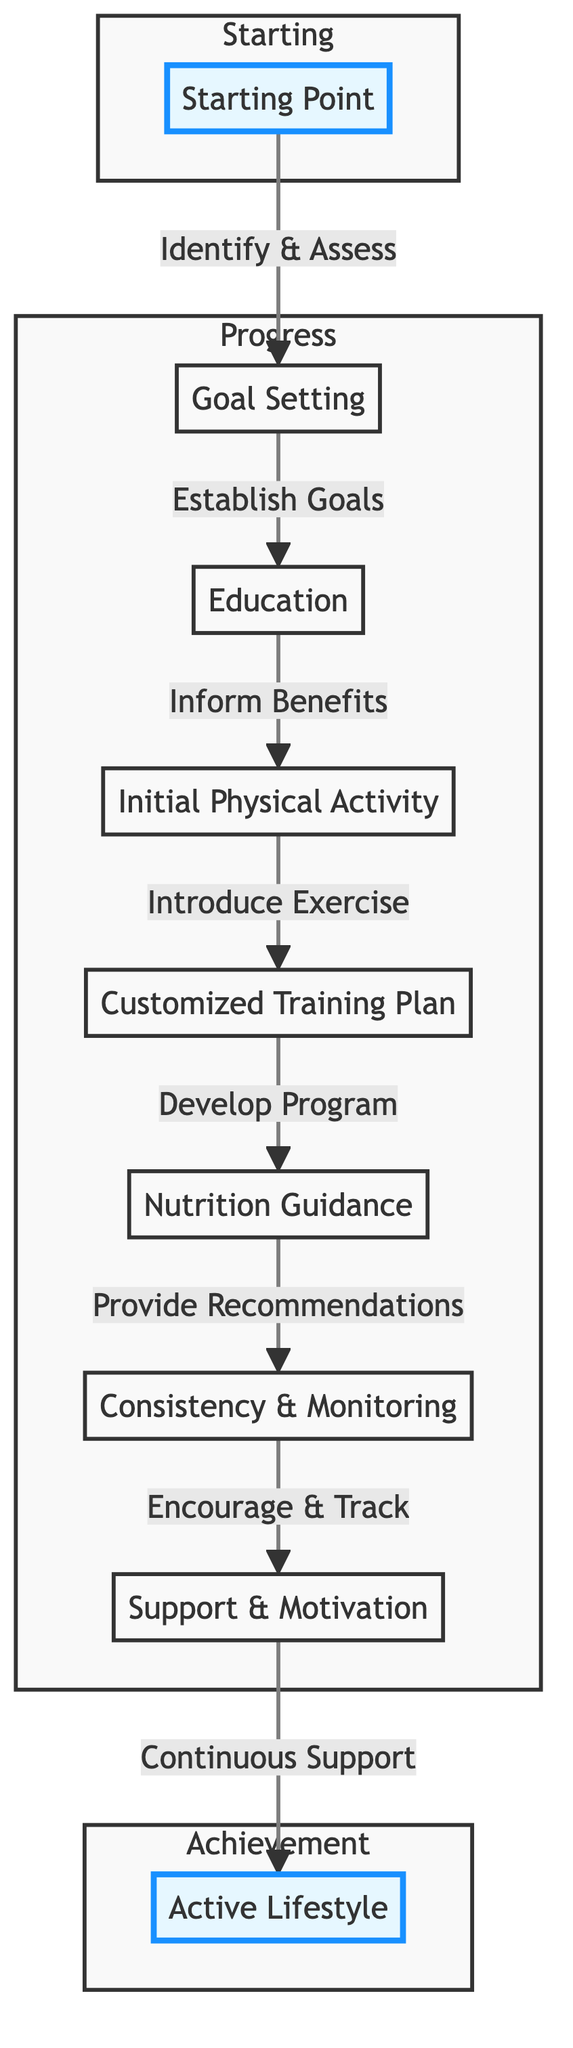What's the starting point in the client's journey? The starting point is indicated as the first node in the diagram, which describes the identification of a sedentary lifestyle and readiness to change.
Answer: Starting Point How many total stages are in the client’s journey? To find the total stages, count the nodes present in the flow chart. There are nine stages from Starting Point to Active Lifestyle.
Answer: 9 Which stage comes after Goal Setting? The flow of the diagram shows that the first stage leads to the next; after Goal Setting, the client moves to the Education stage.
Answer: Education What activity is included in the Initial Physical Activity stage? By examining the details of the Initial Physical Activity stage, we see two specified activities: Walking and Stretching.
Answer: Walking, Stretching What tools are used in the Customized Training Plan stage? The Customized Training Plan stage mentions two specific tools that facilitate this stage: Personalized Workout Plan and Progress Tracker.
Answer: Personalized Workout Plan, Progress Tracker What is the last stage of the client's journey? The last node in the flow chart indicates the final stage, which is focused on achieving an active lifestyle following a drug-free approach.
Answer: Active Lifestyle What stage is responsible for providing nutritional guidance? Looking at the flow of the stages, the Nutrition Guidance stage is explicitly listed between Customized Training Plan and Consistency & Monitoring.
Answer: Nutrition Guidance How does Support & Motivation relate to the previous stage? By reviewing the flow of the chart, Support & Motivation is positioned directly after Consistency & Monitoring, signifying the type of ongoing assistance provided.
Answer: After Consistency & Monitoring Which two activities are highlighted in the Active Lifestyle stage? The Active Lifestyle stage includes two activities that embody the goal of maintaining an active, drug-free lifestyle: Advanced Training and Community Involvement.
Answer: Advanced Training, Community Involvement 